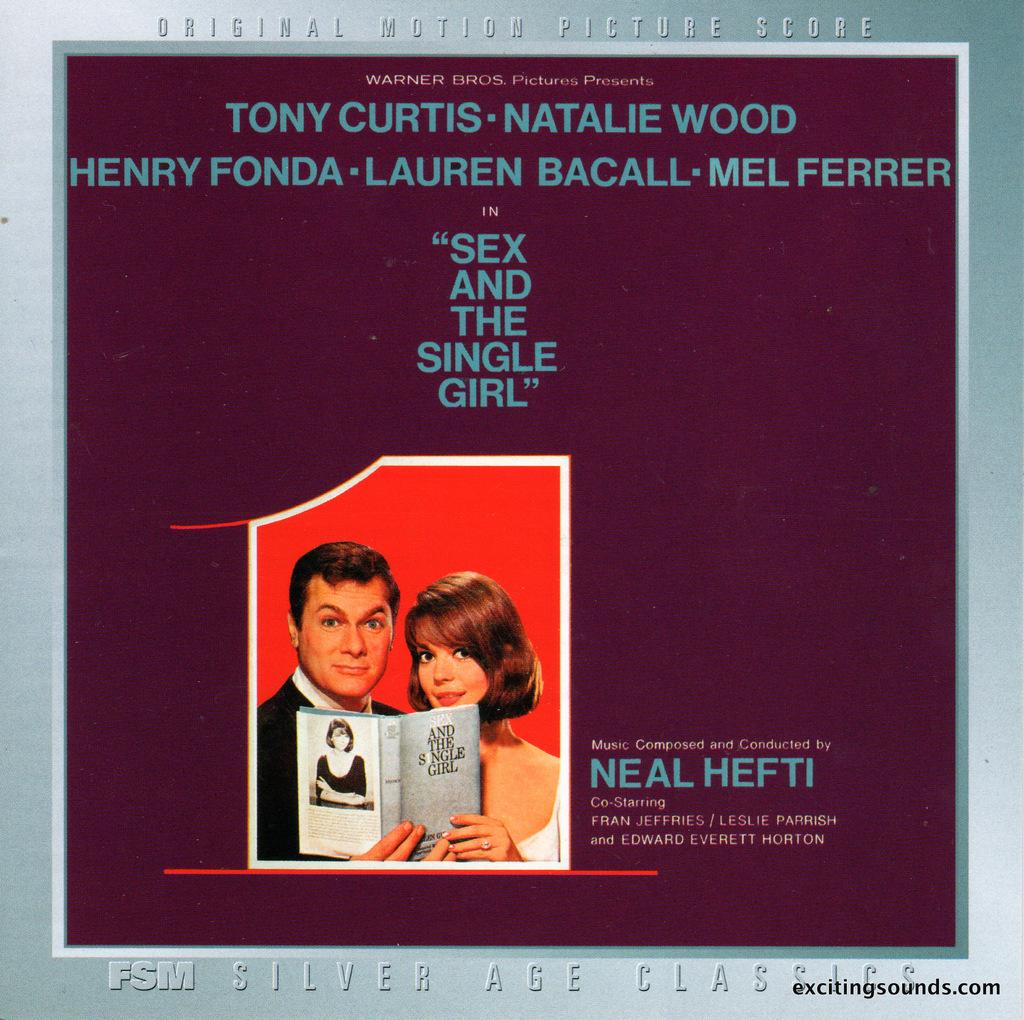What is present on the wall in the image? There is a poster on the wall in the image. What is depicted on the poster? The poster depicts a man and a woman holding a book. Are there any visible marks or imperfections in the image? Yes, there are watermarks at the bottom of the image. Where is the poster located in relation to the wall? The poster is placed on the wall. How does the man in the poster react to the loss of his favorite chain? There is no mention of a chain or any loss in the image or the provided facts, so this question cannot be answered. 